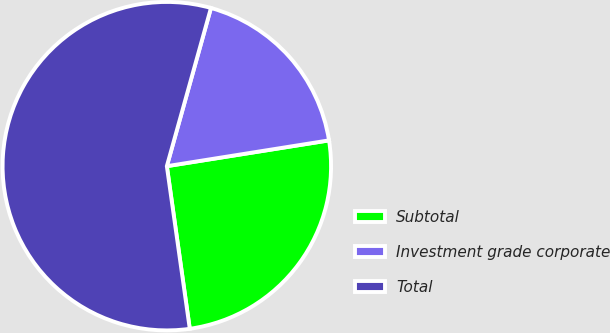Convert chart to OTSL. <chart><loc_0><loc_0><loc_500><loc_500><pie_chart><fcel>Subtotal<fcel>Investment grade corporate<fcel>Total<nl><fcel>25.28%<fcel>18.16%<fcel>56.56%<nl></chart> 